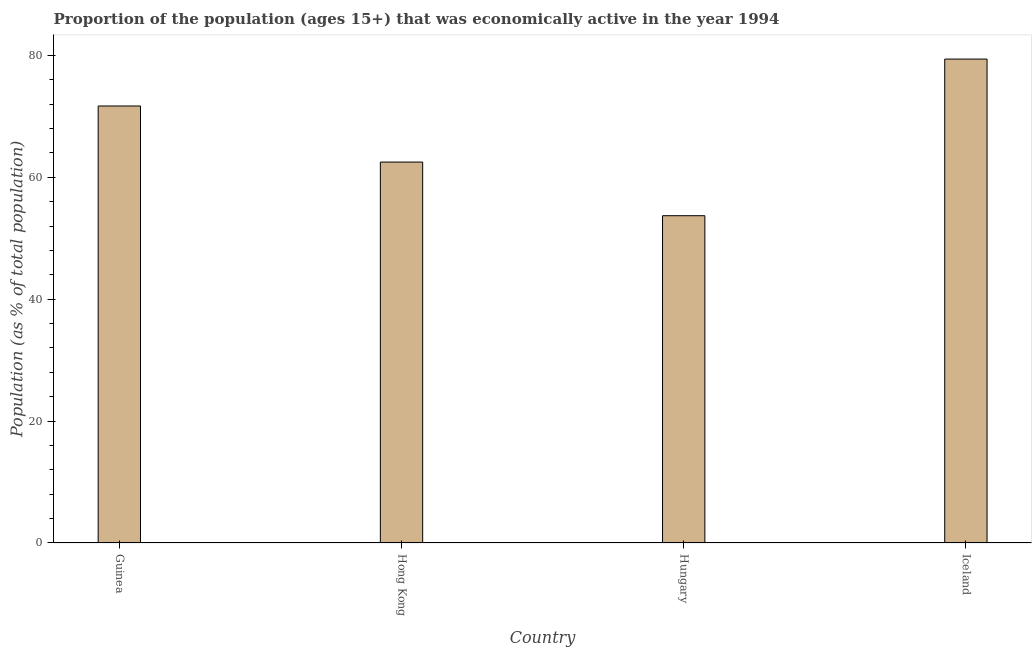Does the graph contain any zero values?
Give a very brief answer. No. What is the title of the graph?
Your answer should be compact. Proportion of the population (ages 15+) that was economically active in the year 1994. What is the label or title of the X-axis?
Offer a terse response. Country. What is the label or title of the Y-axis?
Your answer should be very brief. Population (as % of total population). What is the percentage of economically active population in Guinea?
Make the answer very short. 71.7. Across all countries, what is the maximum percentage of economically active population?
Ensure brevity in your answer.  79.4. Across all countries, what is the minimum percentage of economically active population?
Provide a short and direct response. 53.7. In which country was the percentage of economically active population minimum?
Ensure brevity in your answer.  Hungary. What is the sum of the percentage of economically active population?
Your answer should be compact. 267.3. What is the difference between the percentage of economically active population in Hong Kong and Iceland?
Offer a very short reply. -16.9. What is the average percentage of economically active population per country?
Your response must be concise. 66.83. What is the median percentage of economically active population?
Your answer should be very brief. 67.1. What is the ratio of the percentage of economically active population in Hungary to that in Iceland?
Ensure brevity in your answer.  0.68. Is the percentage of economically active population in Hong Kong less than that in Iceland?
Ensure brevity in your answer.  Yes. What is the difference between the highest and the second highest percentage of economically active population?
Offer a terse response. 7.7. Is the sum of the percentage of economically active population in Guinea and Iceland greater than the maximum percentage of economically active population across all countries?
Offer a very short reply. Yes. What is the difference between the highest and the lowest percentage of economically active population?
Your answer should be very brief. 25.7. How many bars are there?
Offer a terse response. 4. Are all the bars in the graph horizontal?
Provide a short and direct response. No. How many countries are there in the graph?
Your answer should be very brief. 4. What is the difference between two consecutive major ticks on the Y-axis?
Your answer should be very brief. 20. Are the values on the major ticks of Y-axis written in scientific E-notation?
Make the answer very short. No. What is the Population (as % of total population) of Guinea?
Offer a terse response. 71.7. What is the Population (as % of total population) in Hong Kong?
Your response must be concise. 62.5. What is the Population (as % of total population) of Hungary?
Offer a very short reply. 53.7. What is the Population (as % of total population) in Iceland?
Ensure brevity in your answer.  79.4. What is the difference between the Population (as % of total population) in Hong Kong and Hungary?
Make the answer very short. 8.8. What is the difference between the Population (as % of total population) in Hong Kong and Iceland?
Your answer should be compact. -16.9. What is the difference between the Population (as % of total population) in Hungary and Iceland?
Give a very brief answer. -25.7. What is the ratio of the Population (as % of total population) in Guinea to that in Hong Kong?
Ensure brevity in your answer.  1.15. What is the ratio of the Population (as % of total population) in Guinea to that in Hungary?
Your answer should be compact. 1.33. What is the ratio of the Population (as % of total population) in Guinea to that in Iceland?
Give a very brief answer. 0.9. What is the ratio of the Population (as % of total population) in Hong Kong to that in Hungary?
Your answer should be very brief. 1.16. What is the ratio of the Population (as % of total population) in Hong Kong to that in Iceland?
Make the answer very short. 0.79. What is the ratio of the Population (as % of total population) in Hungary to that in Iceland?
Offer a terse response. 0.68. 